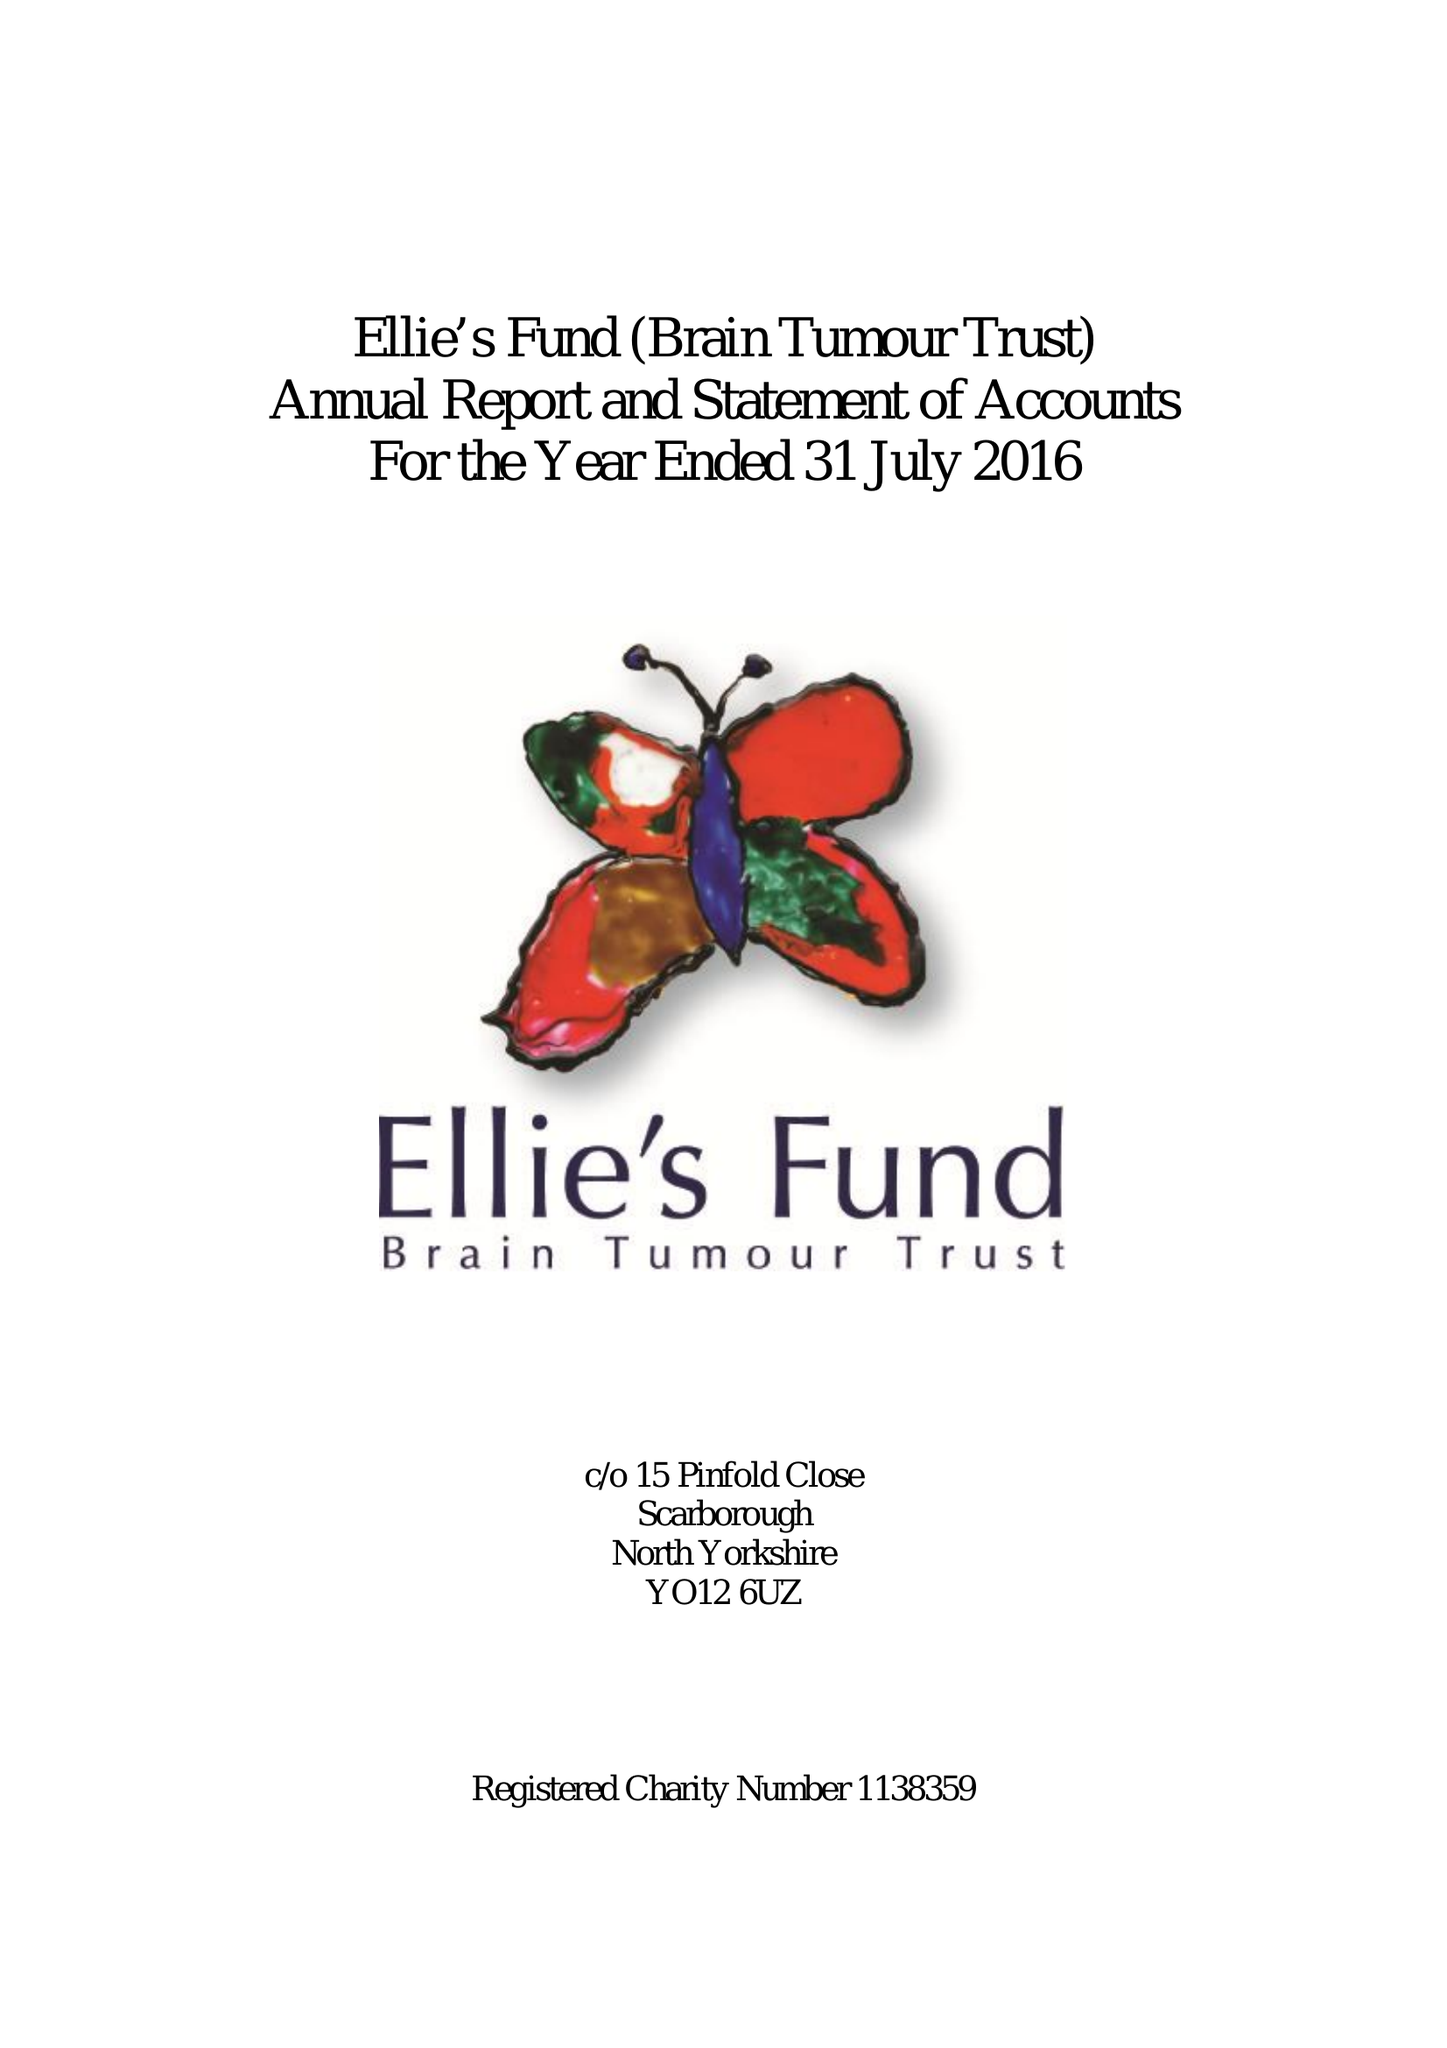What is the value for the report_date?
Answer the question using a single word or phrase. 2016-07-31 